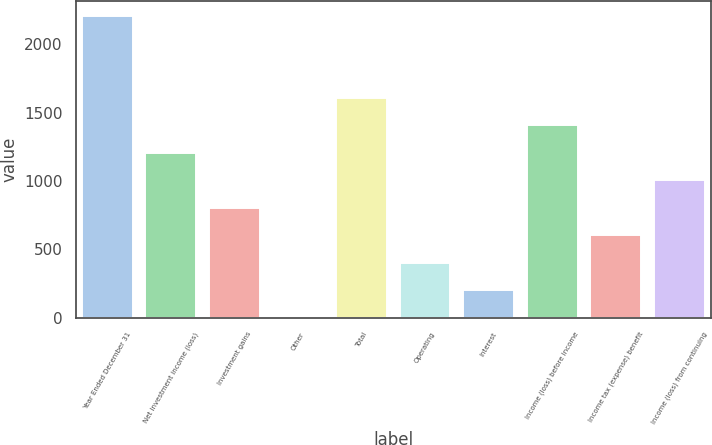<chart> <loc_0><loc_0><loc_500><loc_500><bar_chart><fcel>Year Ended December 31<fcel>Net investment income (loss)<fcel>Investment gains<fcel>Other<fcel>Total<fcel>Operating<fcel>Interest<fcel>Income (loss) before income<fcel>Income tax (expense) benefit<fcel>Income (loss) from continuing<nl><fcel>2207.5<fcel>1205<fcel>804<fcel>2<fcel>1606<fcel>403<fcel>202.5<fcel>1405.5<fcel>603.5<fcel>1004.5<nl></chart> 